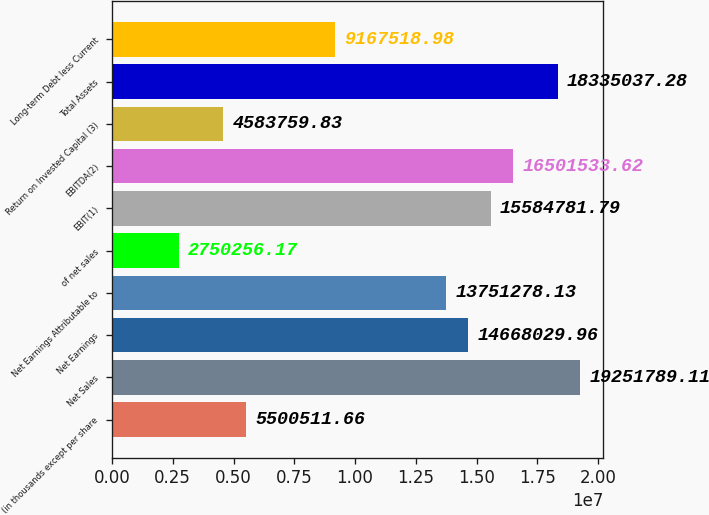<chart> <loc_0><loc_0><loc_500><loc_500><bar_chart><fcel>(in thousands except per share<fcel>Net Sales<fcel>Net Earnings<fcel>Net Earnings Attributable to<fcel>of net sales<fcel>EBIT(1)<fcel>EBITDA(2)<fcel>Return on Invested Capital (3)<fcel>Total Assets<fcel>Long-term Debt less Current<nl><fcel>5.50051e+06<fcel>1.92518e+07<fcel>1.4668e+07<fcel>1.37513e+07<fcel>2.75026e+06<fcel>1.55848e+07<fcel>1.65015e+07<fcel>4.58376e+06<fcel>1.8335e+07<fcel>9.16752e+06<nl></chart> 